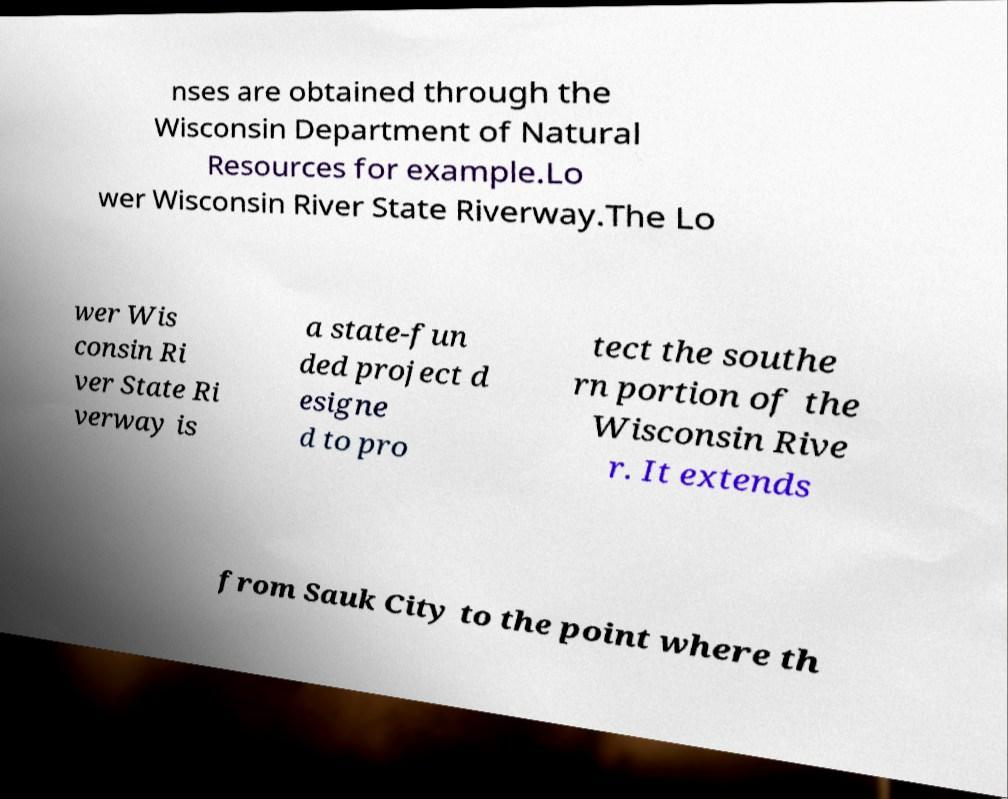Can you accurately transcribe the text from the provided image for me? nses are obtained through the Wisconsin Department of Natural Resources for example.Lo wer Wisconsin River State Riverway.The Lo wer Wis consin Ri ver State Ri verway is a state-fun ded project d esigne d to pro tect the southe rn portion of the Wisconsin Rive r. It extends from Sauk City to the point where th 